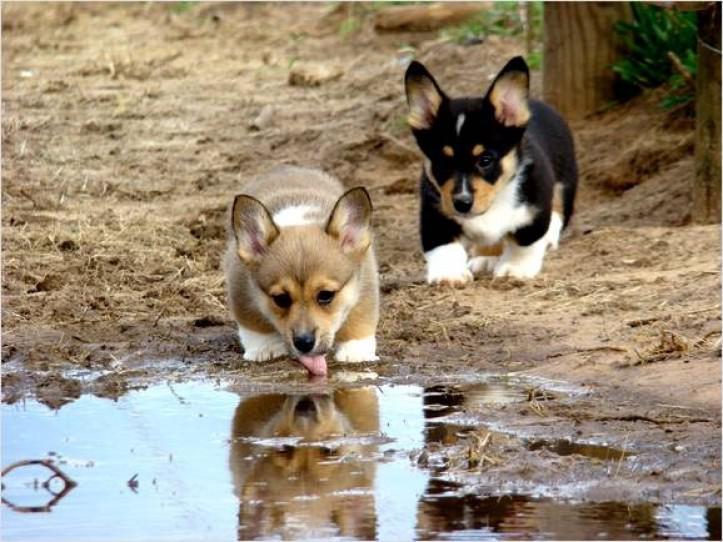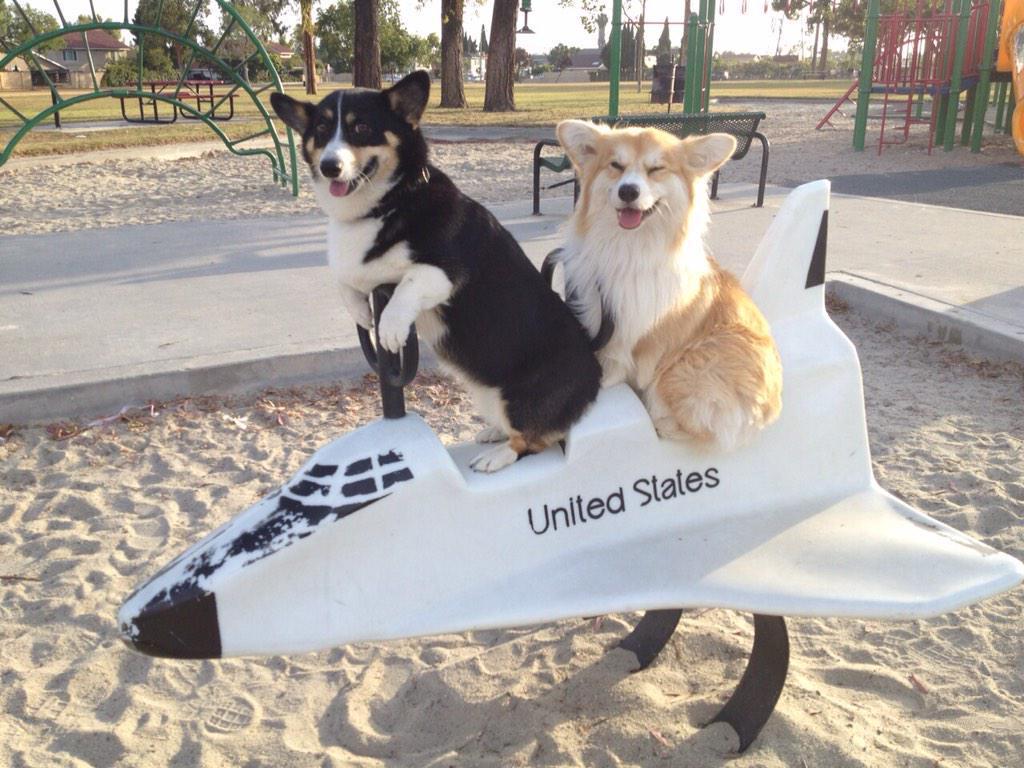The first image is the image on the left, the second image is the image on the right. Analyze the images presented: Is the assertion "One if the images has three dogs looking at the camera." valid? Answer yes or no. No. The first image is the image on the left, the second image is the image on the right. For the images shown, is this caption "The left image shows one corgi with its rear to the camera, standing on all fours and looking over one shoulder." true? Answer yes or no. No. 